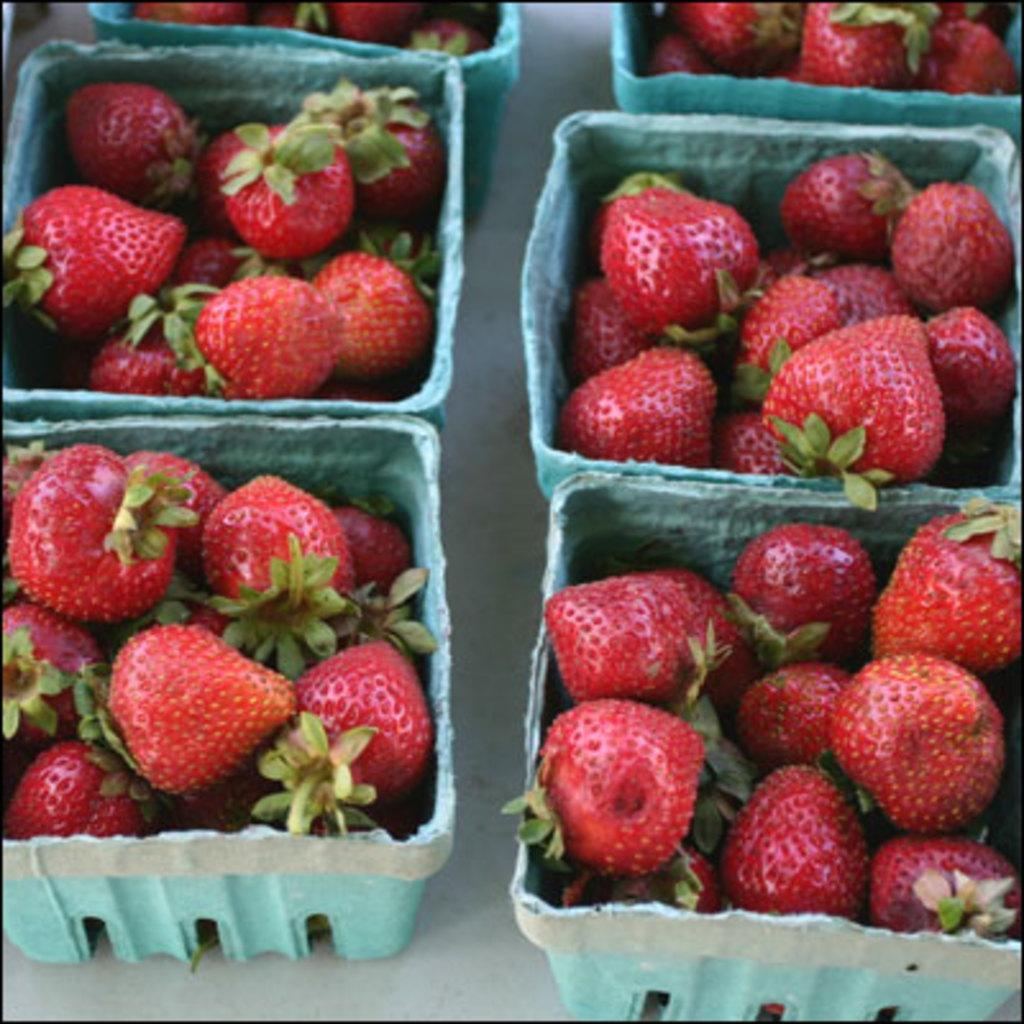What is the color of the surface in the image? The surface in the image is white. What objects are on the surface? There are blue trays on the surface. What is inside the trays? The trays contain strawberries. What color are the strawberries? The strawberries are red in color. What can be seen on the strawberries besides the fruit itself? The strawberries have green leaves. What type of advice is being given in the image? There is no advice being given in the image; it features blue trays with strawberries on a white surface. Is there a tent visible in the image? No, there is no tent present in the image. 